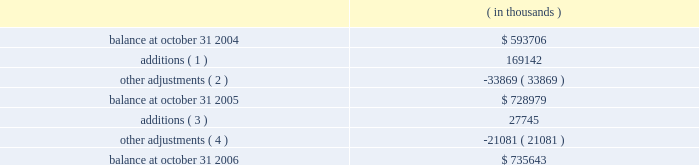Fiscal 2004 acquisitions in february 2004 , the company completed the acquisition of all the outstanding shares of accelerant networks , inc .
( accelerant ) for total consideration of $ 23.8 million , and the acquisition of the technology assets of analog design automation , inc .
( ada ) for total consideration of $ 12.2 million .
The company acquired accelerant in order to enhance the company 2019s standards-based ip solutions .
The company acquired the assets of ada in order to enhance the company 2019s analog and mixed signal offerings .
In october 2004 , the company completed the acquisition of cascade semiconductor solutions , inc .
( cascade ) for total upfront consideration of $ 15.8 million and contingent consideration of up to $ 10.0 million to be paid upon the achievement of certain performance milestones over the three years following the acquisition .
Contingent consideration totaling $ 2.1 million was paid during the fourth quarter of fiscal 2005 and has been allocated to goodwill .
The company acquired cascade , an ip provider , in order to augment synopsys 2019 offerings of pci express products .
Included in the total consideration for the accelerant and cascade acquisitions are aggregate acquisition costs of $ 4.3 million , consisting primarily of legal and accounting fees and other directly related charges .
As of october 31 , 2006 the company has paid substantially all the costs related to these acquisitions .
In fiscal 2004 , the company completed one additional acquisition and two additional asset acquisition transactions for aggregate consideration of $ 12.3 million in upfront payments and acquisition-related costs .
In process research and development expenses associated with these acquisitions totaled $ 1.6 million for fiscal 2004 .
These acquisitions are not considered material , individually or in the aggregate , to the company 2019s consolidated balance sheet and results of operations .
As of october 31 , 2006 , the company has paid substantially all the costs related to these acquisitions .
The company allocated the total aggregate purchase consideration for these transactions to the assets and liabilities acquired , including identifiable intangible assets , based on their respective fair values at the acquisition dates , resulting in aggregate goodwill of $ 24.5 million .
Aggregate identifiable intangible assets as a result of these acquisitions , consisting primarily of purchased technology and other intangibles , are $ 44.8 million , and are being amortized over three to five years .
The company includes the amortization of purchased technology in cost of revenue in its statements of operations .
Note 4 .
Goodwill and intangible assets goodwill consists of the following: .
( 1 ) during fiscal year 2005 , additions represent goodwill acquired in acquisitions of ise and nassda of $ 72.9 million and $ 92.4 million , respectively , and contingent consideration earned and paid of $ 1.7 million and $ 2.1 million related to an immaterial acquisition and the acquisition of cascade , respectively .
( 2 ) during fiscal year 2005 , synopsys reduced goodwill primarily related to tax reserves for avant! no longer probable due to expiration of the federal statute of limitations for claims. .
What is the variation observed in the balance between 2005 and 2006 , in thousands? 
Rationale: it is the difference between those values .
Computations: (735643 - 728979)
Answer: 6664.0. 